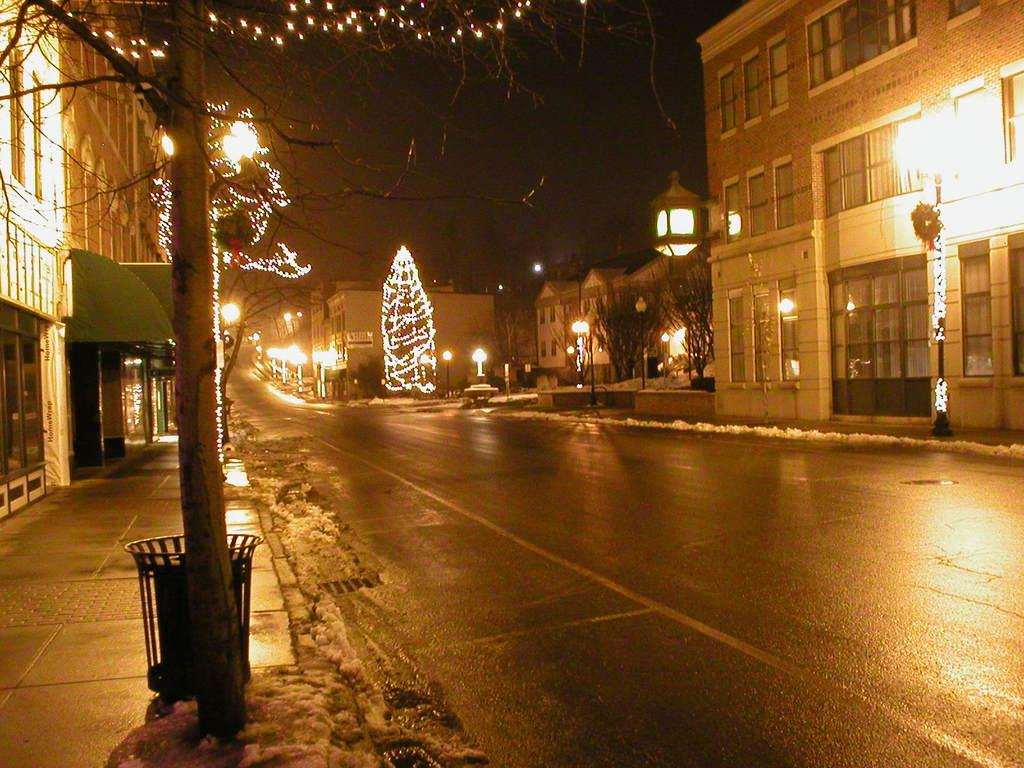What type of structures can be seen in the image? There are buildings in the image. What natural elements are present in the image? There are trees in the image. What are the vertical objects in the image? There are poles in the image. What are the illuminating objects in the image? There are lights in the image. Where is the dustbin located in the image? The dustbin is on the left side of the image. What type of representative is present in the image? There is no representative present in the image. What type of flag can be seen in the image? There is no flag present in the image. 